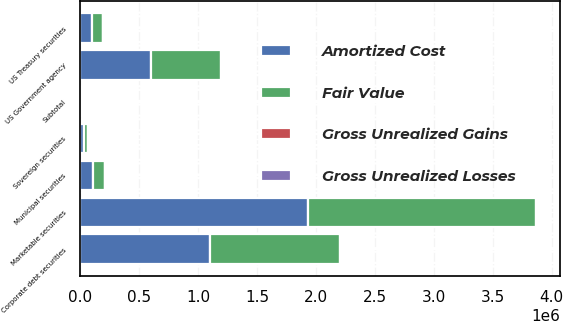Convert chart. <chart><loc_0><loc_0><loc_500><loc_500><stacked_bar_chart><ecel><fcel>US Treasury securities<fcel>US Government agency<fcel>Municipal securities<fcel>Corporate debt securities<fcel>Sovereign securities<fcel>Subtotal<fcel>Marketable securities<nl><fcel>Fair Value<fcel>93940<fcel>598471<fcel>103686<fcel>1.10344e+06<fcel>33799<fcel>4002<fcel>1.93442e+06<nl><fcel>Gross Unrealized Gains<fcel>53<fcel>569<fcel>71<fcel>2353<fcel>25<fcel>3071<fcel>3071<nl><fcel>Gross Unrealized Losses<fcel>206<fcel>1009<fcel>302<fcel>2466<fcel>19<fcel>4002<fcel>4002<nl><fcel>Amortized Cost<fcel>93787<fcel>598031<fcel>103455<fcel>1.10332e+06<fcel>33805<fcel>4002<fcel>1.93349e+06<nl></chart> 